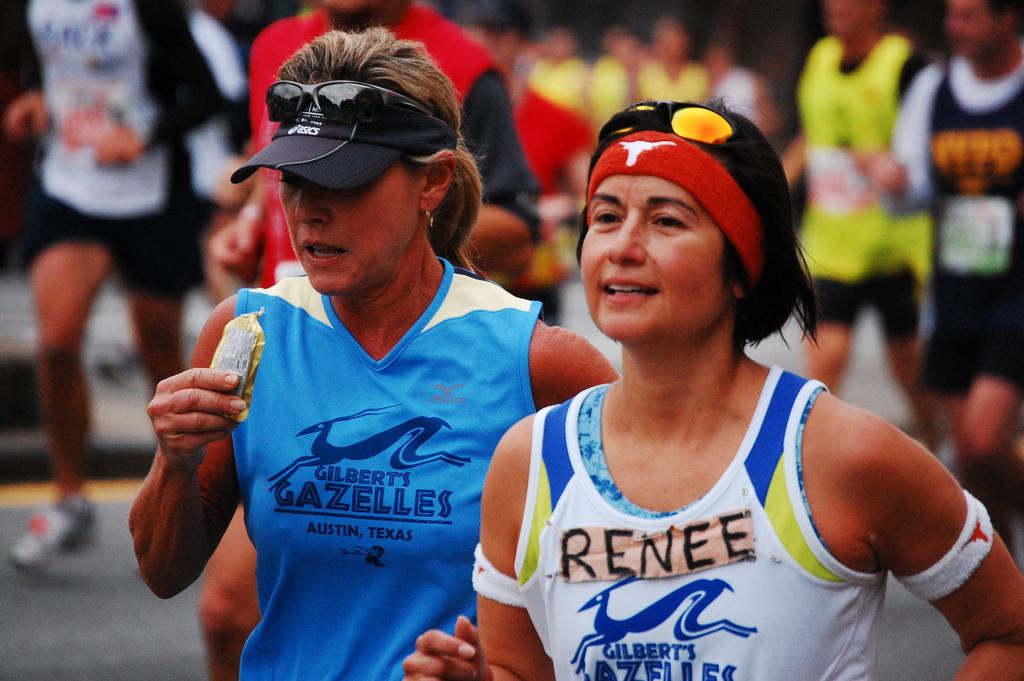What is the woman's name on the shirt?
Your response must be concise. Renee. What brand of shirt is the left womens?
Provide a succinct answer. Gilbert's gazelles. 